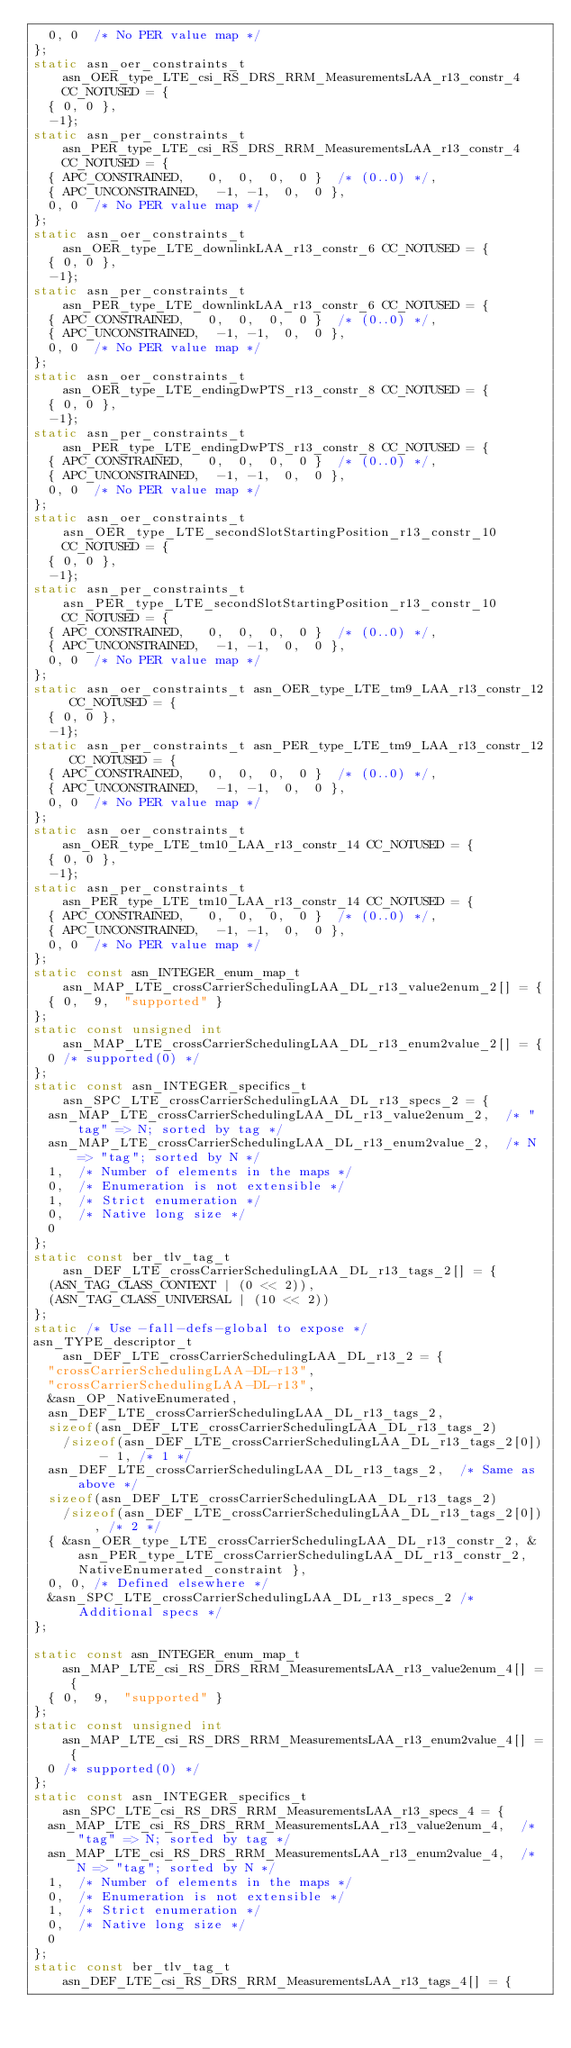Convert code to text. <code><loc_0><loc_0><loc_500><loc_500><_C_>	0, 0	/* No PER value map */
};
static asn_oer_constraints_t asn_OER_type_LTE_csi_RS_DRS_RRM_MeasurementsLAA_r13_constr_4 CC_NOTUSED = {
	{ 0, 0 },
	-1};
static asn_per_constraints_t asn_PER_type_LTE_csi_RS_DRS_RRM_MeasurementsLAA_r13_constr_4 CC_NOTUSED = {
	{ APC_CONSTRAINED,	 0,  0,  0,  0 }	/* (0..0) */,
	{ APC_UNCONSTRAINED,	-1, -1,  0,  0 },
	0, 0	/* No PER value map */
};
static asn_oer_constraints_t asn_OER_type_LTE_downlinkLAA_r13_constr_6 CC_NOTUSED = {
	{ 0, 0 },
	-1};
static asn_per_constraints_t asn_PER_type_LTE_downlinkLAA_r13_constr_6 CC_NOTUSED = {
	{ APC_CONSTRAINED,	 0,  0,  0,  0 }	/* (0..0) */,
	{ APC_UNCONSTRAINED,	-1, -1,  0,  0 },
	0, 0	/* No PER value map */
};
static asn_oer_constraints_t asn_OER_type_LTE_endingDwPTS_r13_constr_8 CC_NOTUSED = {
	{ 0, 0 },
	-1};
static asn_per_constraints_t asn_PER_type_LTE_endingDwPTS_r13_constr_8 CC_NOTUSED = {
	{ APC_CONSTRAINED,	 0,  0,  0,  0 }	/* (0..0) */,
	{ APC_UNCONSTRAINED,	-1, -1,  0,  0 },
	0, 0	/* No PER value map */
};
static asn_oer_constraints_t asn_OER_type_LTE_secondSlotStartingPosition_r13_constr_10 CC_NOTUSED = {
	{ 0, 0 },
	-1};
static asn_per_constraints_t asn_PER_type_LTE_secondSlotStartingPosition_r13_constr_10 CC_NOTUSED = {
	{ APC_CONSTRAINED,	 0,  0,  0,  0 }	/* (0..0) */,
	{ APC_UNCONSTRAINED,	-1, -1,  0,  0 },
	0, 0	/* No PER value map */
};
static asn_oer_constraints_t asn_OER_type_LTE_tm9_LAA_r13_constr_12 CC_NOTUSED = {
	{ 0, 0 },
	-1};
static asn_per_constraints_t asn_PER_type_LTE_tm9_LAA_r13_constr_12 CC_NOTUSED = {
	{ APC_CONSTRAINED,	 0,  0,  0,  0 }	/* (0..0) */,
	{ APC_UNCONSTRAINED,	-1, -1,  0,  0 },
	0, 0	/* No PER value map */
};
static asn_oer_constraints_t asn_OER_type_LTE_tm10_LAA_r13_constr_14 CC_NOTUSED = {
	{ 0, 0 },
	-1};
static asn_per_constraints_t asn_PER_type_LTE_tm10_LAA_r13_constr_14 CC_NOTUSED = {
	{ APC_CONSTRAINED,	 0,  0,  0,  0 }	/* (0..0) */,
	{ APC_UNCONSTRAINED,	-1, -1,  0,  0 },
	0, 0	/* No PER value map */
};
static const asn_INTEGER_enum_map_t asn_MAP_LTE_crossCarrierSchedulingLAA_DL_r13_value2enum_2[] = {
	{ 0,	9,	"supported" }
};
static const unsigned int asn_MAP_LTE_crossCarrierSchedulingLAA_DL_r13_enum2value_2[] = {
	0	/* supported(0) */
};
static const asn_INTEGER_specifics_t asn_SPC_LTE_crossCarrierSchedulingLAA_DL_r13_specs_2 = {
	asn_MAP_LTE_crossCarrierSchedulingLAA_DL_r13_value2enum_2,	/* "tag" => N; sorted by tag */
	asn_MAP_LTE_crossCarrierSchedulingLAA_DL_r13_enum2value_2,	/* N => "tag"; sorted by N */
	1,	/* Number of elements in the maps */
	0,	/* Enumeration is not extensible */
	1,	/* Strict enumeration */
	0,	/* Native long size */
	0
};
static const ber_tlv_tag_t asn_DEF_LTE_crossCarrierSchedulingLAA_DL_r13_tags_2[] = {
	(ASN_TAG_CLASS_CONTEXT | (0 << 2)),
	(ASN_TAG_CLASS_UNIVERSAL | (10 << 2))
};
static /* Use -fall-defs-global to expose */
asn_TYPE_descriptor_t asn_DEF_LTE_crossCarrierSchedulingLAA_DL_r13_2 = {
	"crossCarrierSchedulingLAA-DL-r13",
	"crossCarrierSchedulingLAA-DL-r13",
	&asn_OP_NativeEnumerated,
	asn_DEF_LTE_crossCarrierSchedulingLAA_DL_r13_tags_2,
	sizeof(asn_DEF_LTE_crossCarrierSchedulingLAA_DL_r13_tags_2)
		/sizeof(asn_DEF_LTE_crossCarrierSchedulingLAA_DL_r13_tags_2[0]) - 1, /* 1 */
	asn_DEF_LTE_crossCarrierSchedulingLAA_DL_r13_tags_2,	/* Same as above */
	sizeof(asn_DEF_LTE_crossCarrierSchedulingLAA_DL_r13_tags_2)
		/sizeof(asn_DEF_LTE_crossCarrierSchedulingLAA_DL_r13_tags_2[0]), /* 2 */
	{ &asn_OER_type_LTE_crossCarrierSchedulingLAA_DL_r13_constr_2, &asn_PER_type_LTE_crossCarrierSchedulingLAA_DL_r13_constr_2, NativeEnumerated_constraint },
	0, 0,	/* Defined elsewhere */
	&asn_SPC_LTE_crossCarrierSchedulingLAA_DL_r13_specs_2	/* Additional specs */
};

static const asn_INTEGER_enum_map_t asn_MAP_LTE_csi_RS_DRS_RRM_MeasurementsLAA_r13_value2enum_4[] = {
	{ 0,	9,	"supported" }
};
static const unsigned int asn_MAP_LTE_csi_RS_DRS_RRM_MeasurementsLAA_r13_enum2value_4[] = {
	0	/* supported(0) */
};
static const asn_INTEGER_specifics_t asn_SPC_LTE_csi_RS_DRS_RRM_MeasurementsLAA_r13_specs_4 = {
	asn_MAP_LTE_csi_RS_DRS_RRM_MeasurementsLAA_r13_value2enum_4,	/* "tag" => N; sorted by tag */
	asn_MAP_LTE_csi_RS_DRS_RRM_MeasurementsLAA_r13_enum2value_4,	/* N => "tag"; sorted by N */
	1,	/* Number of elements in the maps */
	0,	/* Enumeration is not extensible */
	1,	/* Strict enumeration */
	0,	/* Native long size */
	0
};
static const ber_tlv_tag_t asn_DEF_LTE_csi_RS_DRS_RRM_MeasurementsLAA_r13_tags_4[] = {</code> 